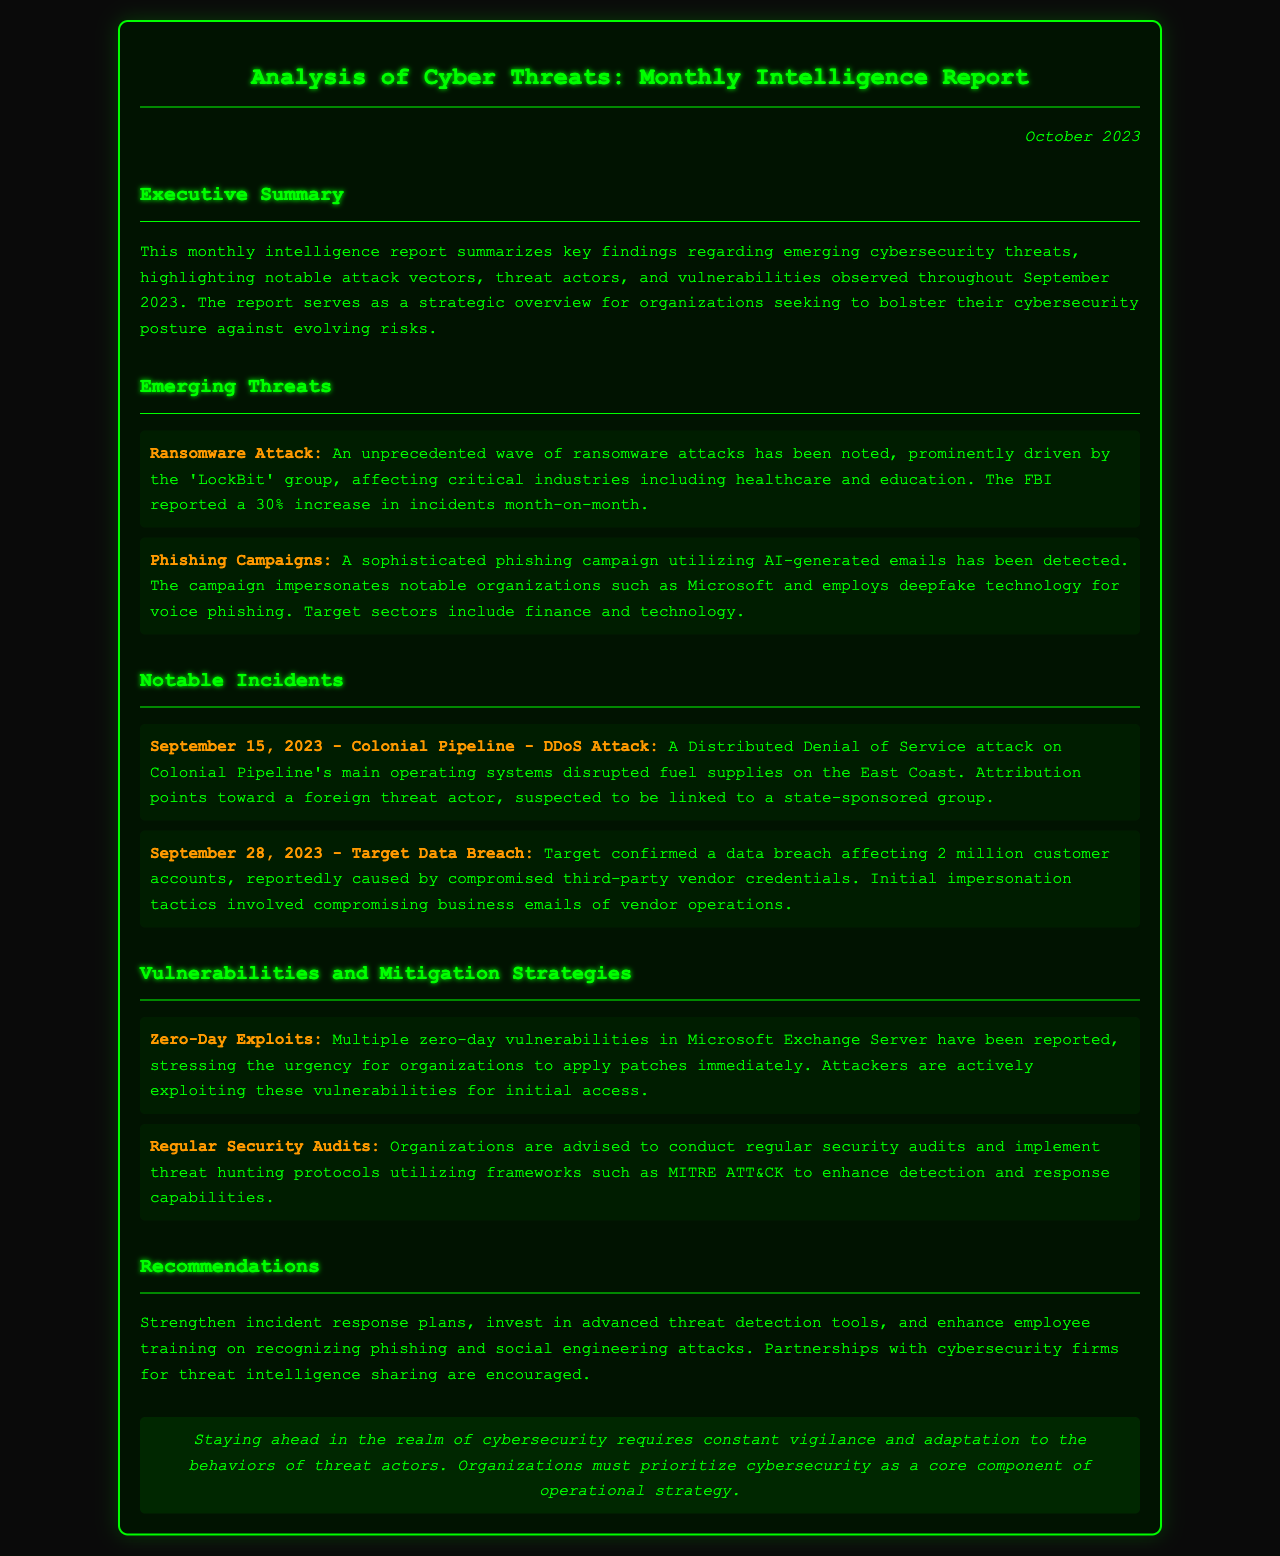What notable group is associated with the recent ransomware attacks? The report mentions the 'LockBit' group as prominently driving the recent ransomware attacks.
Answer: LockBit What percentage increase in ransomware incidents was reported by the FBI? The document states that the FBI reported a 30% increase in ransomware incidents month-on-month.
Answer: 30% What type of attack disrupted Colonial Pipeline's fuel supplies? The attack on Colonial Pipeline's operating systems was a Distributed Denial of Service attack.
Answer: DDoS Attack On what date did the Target data breach occur? The document specifies that the Target data breach occurred on September 28, 2023.
Answer: September 28, 2023 What is one recommended strategy for organizations to enhance cybersecurity? The report suggests conducting regular security audits to enhance detection and response capabilities.
Answer: Regular Security Audits Which technology was used in the sophisticated phishing campaign? The phishing campaign utilized deepfake technology for voice phishing.
Answer: Deepfake technology What urgent action is advised for vulnerabilities in Microsoft Exchange Server? Organizations are urged to apply patches immediately for the reported zero-day vulnerabilities.
Answer: Apply patches immediately What is the document's purpose? The report serves as a strategic overview for organizations seeking to bolster their cybersecurity posture against evolving risks.
Answer: Strategic overview 